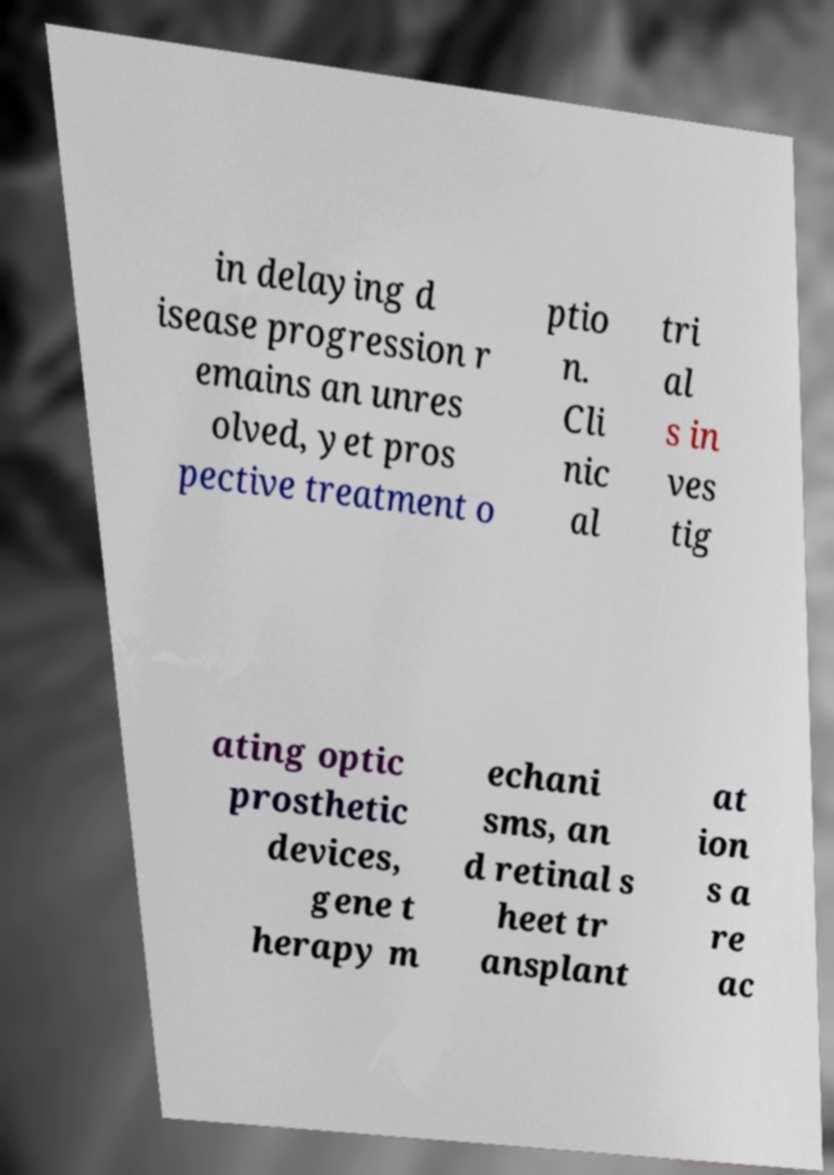There's text embedded in this image that I need extracted. Can you transcribe it verbatim? in delaying d isease progression r emains an unres olved, yet pros pective treatment o ptio n. Cli nic al tri al s in ves tig ating optic prosthetic devices, gene t herapy m echani sms, an d retinal s heet tr ansplant at ion s a re ac 